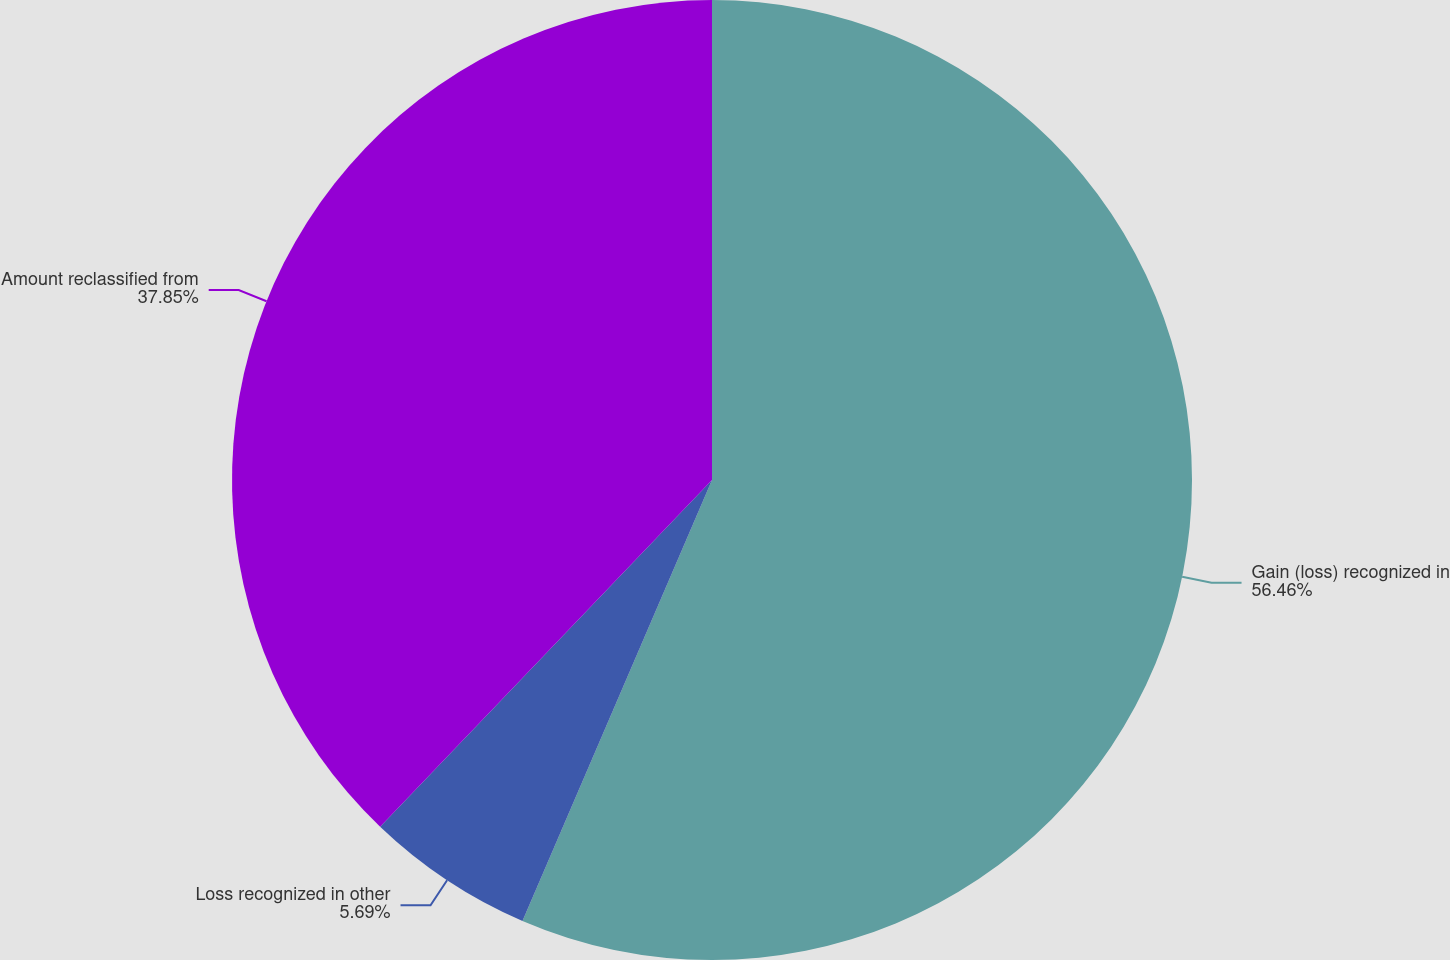<chart> <loc_0><loc_0><loc_500><loc_500><pie_chart><fcel>Gain (loss) recognized in<fcel>Loss recognized in other<fcel>Amount reclassified from<nl><fcel>56.46%<fcel>5.69%<fcel>37.85%<nl></chart> 